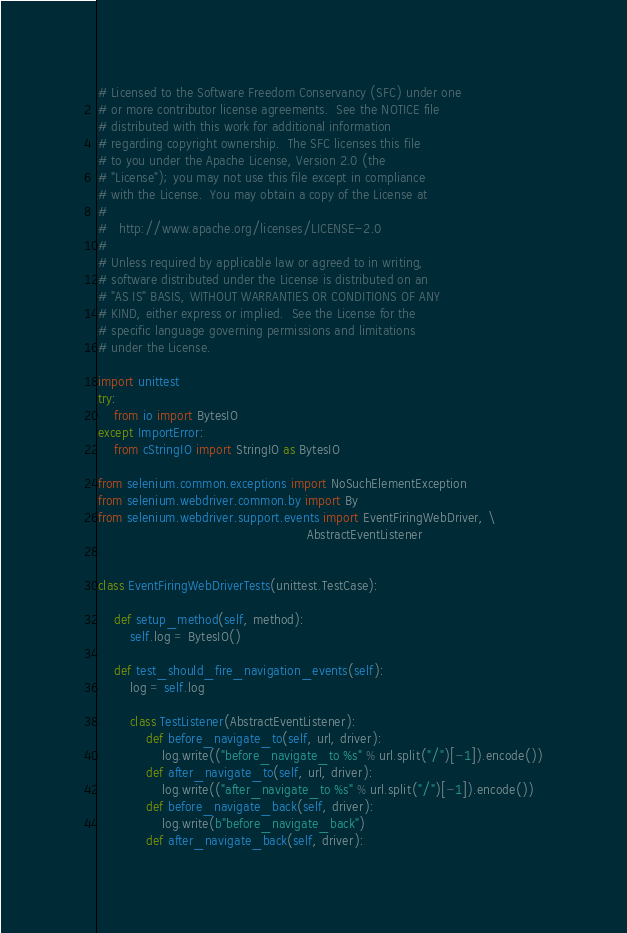<code> <loc_0><loc_0><loc_500><loc_500><_Python_># Licensed to the Software Freedom Conservancy (SFC) under one
# or more contributor license agreements.  See the NOTICE file
# distributed with this work for additional information
# regarding copyright ownership.  The SFC licenses this file
# to you under the Apache License, Version 2.0 (the
# "License"); you may not use this file except in compliance
# with the License.  You may obtain a copy of the License at
#
#   http://www.apache.org/licenses/LICENSE-2.0
#
# Unless required by applicable law or agreed to in writing,
# software distributed under the License is distributed on an
# "AS IS" BASIS, WITHOUT WARRANTIES OR CONDITIONS OF ANY
# KIND, either express or implied.  See the License for the
# specific language governing permissions and limitations
# under the License.

import unittest
try:
    from io import BytesIO
except ImportError:
    from cStringIO import StringIO as BytesIO

from selenium.common.exceptions import NoSuchElementException
from selenium.webdriver.common.by import By
from selenium.webdriver.support.events import EventFiringWebDriver, \
                                                    AbstractEventListener


class EventFiringWebDriverTests(unittest.TestCase):

    def setup_method(self, method):
        self.log = BytesIO()

    def test_should_fire_navigation_events(self):
        log = self.log

        class TestListener(AbstractEventListener):
            def before_navigate_to(self, url, driver):
                log.write(("before_navigate_to %s" % url.split("/")[-1]).encode())
            def after_navigate_to(self, url, driver):
                log.write(("after_navigate_to %s" % url.split("/")[-1]).encode())
            def before_navigate_back(self, driver):
                log.write(b"before_navigate_back")
            def after_navigate_back(self, driver):</code> 